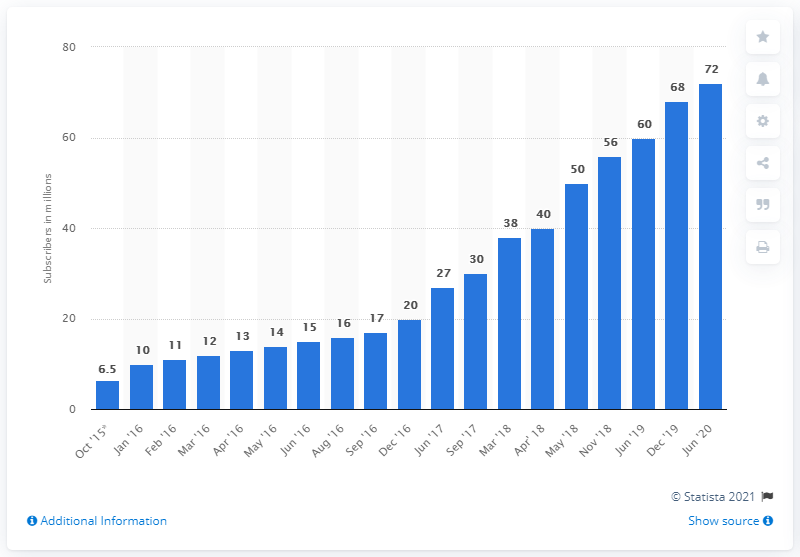Mention a couple of crucial points in this snapshot. In June 2020, Apple Music had 72 million global subscribers. 